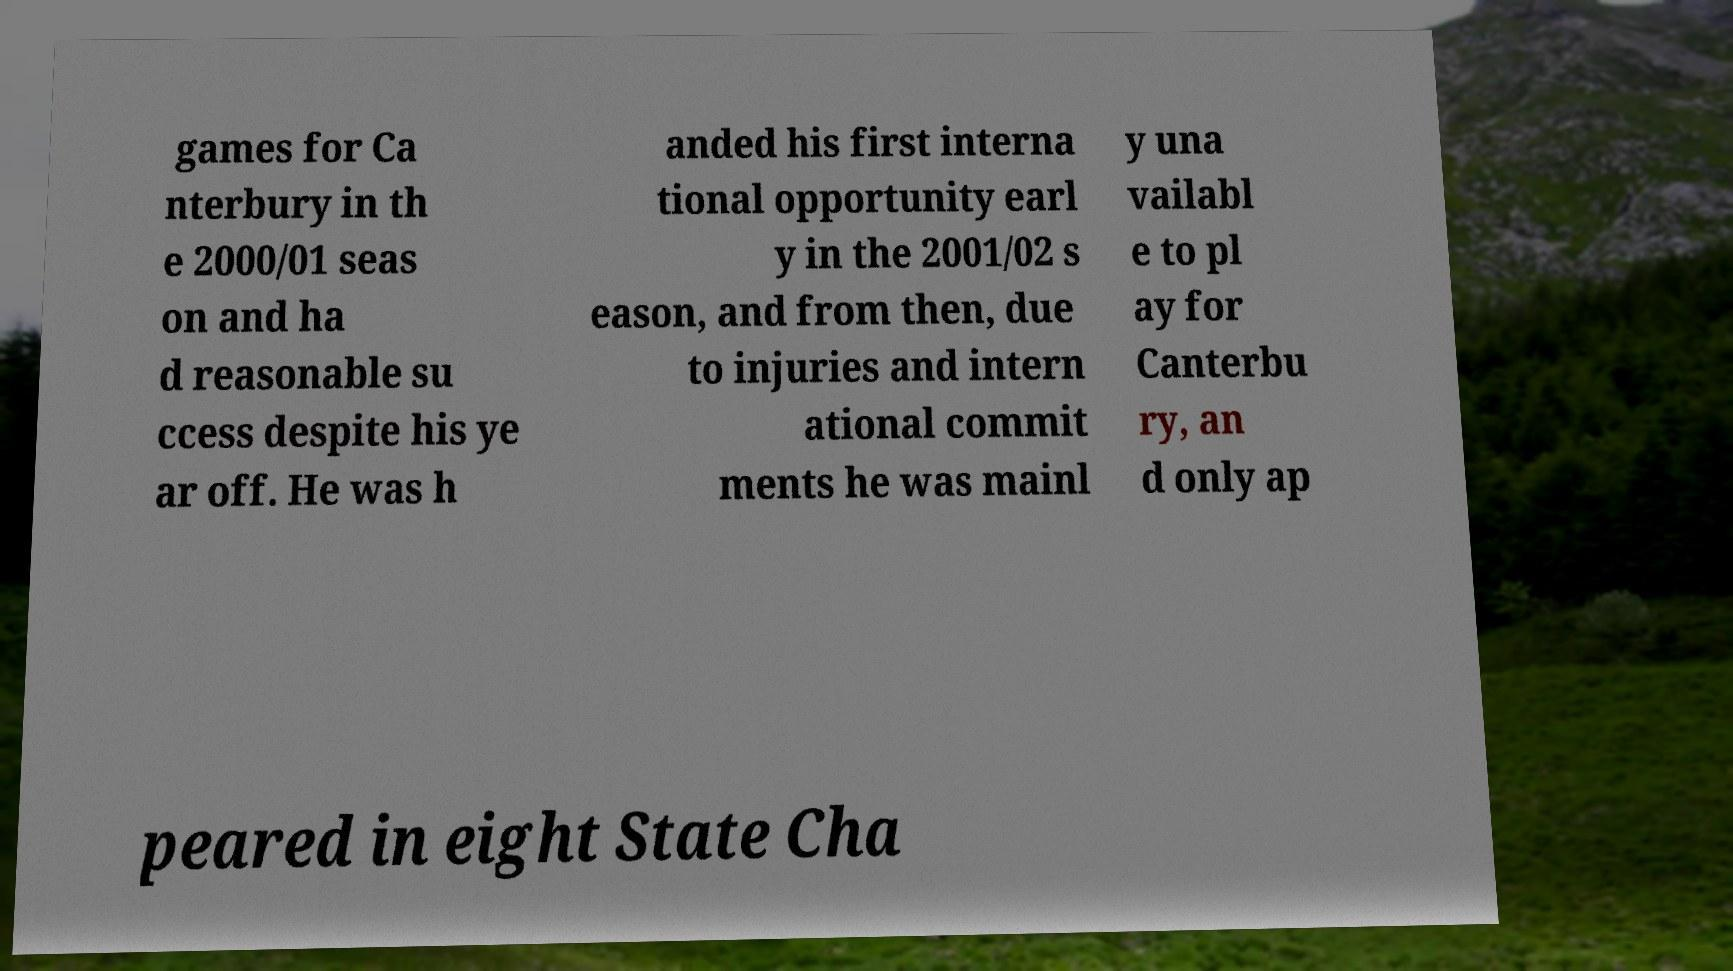I need the written content from this picture converted into text. Can you do that? games for Ca nterbury in th e 2000/01 seas on and ha d reasonable su ccess despite his ye ar off. He was h anded his first interna tional opportunity earl y in the 2001/02 s eason, and from then, due to injuries and intern ational commit ments he was mainl y una vailabl e to pl ay for Canterbu ry, an d only ap peared in eight State Cha 